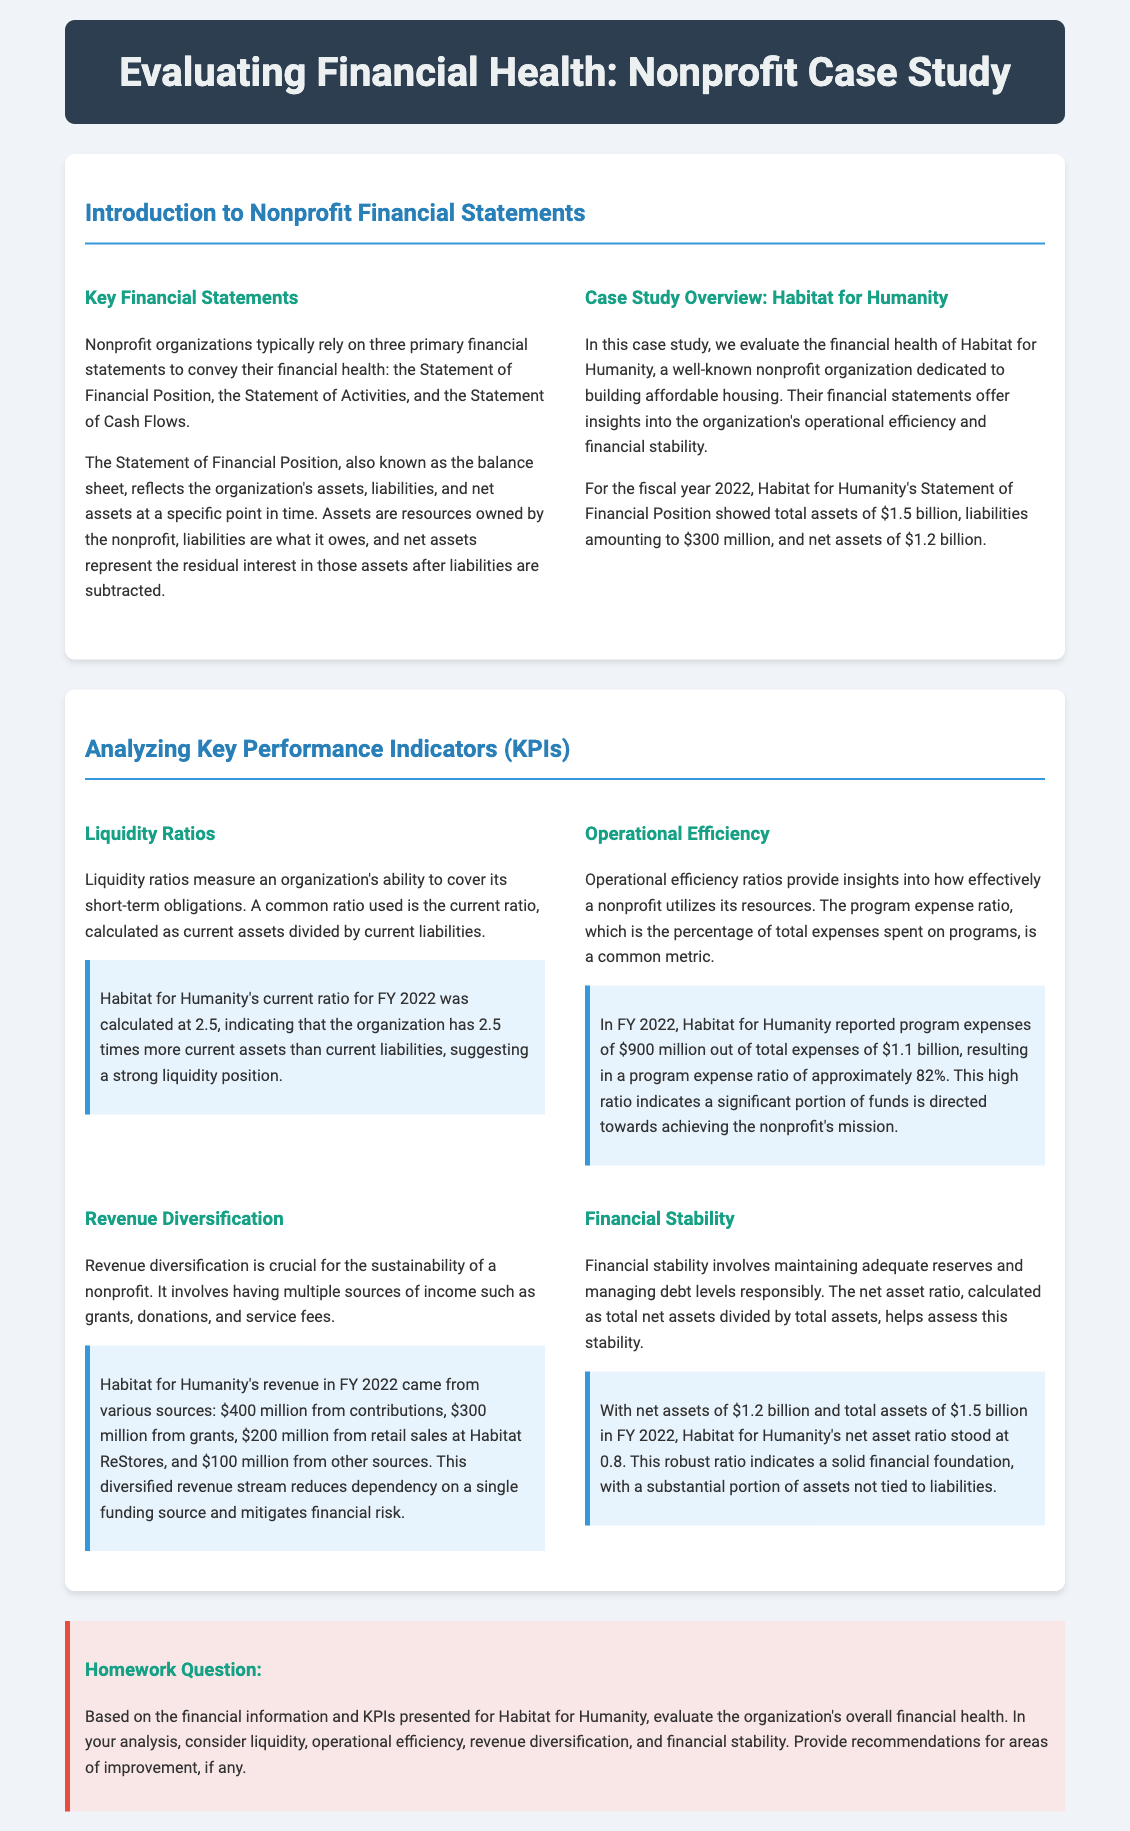What are the three primary financial statements used by nonprofits? The document states that nonprofit organizations typically rely on the Statement of Financial Position, Statement of Activities, and Statement of Cash Flows.
Answer: Statement of Financial Position, Statement of Activities, Statement of Cash Flows What were Habitat for Humanity's total assets for FY 2022? According to the case study, Habitat for Humanity's total assets for FY 2022 were reported as $1.5 billion.
Answer: $1.5 billion What is Habitat for Humanity's program expense ratio for FY 2022? The document indicates that Habitat for Humanity reported a program expense ratio of approximately 82% for FY 2022.
Answer: 82% What does a current ratio of 2.5 indicate about Habitat for Humanity? The current ratio of 2.5 suggests that the organization has 2.5 times more current assets than current liabilities, indicating a strong liquidity position.
Answer: Strong liquidity position How much revenue did Habitat for Humanity generate from contributions in FY 2022? The document states that Habitat for Humanity's revenue from contributions in FY 2022 was $400 million.
Answer: $400 million What is the net asset ratio for Habitat for Humanity in FY 2022? According to the document, Habitat for Humanity's net asset ratio for FY 2022 was calculated as 0.8.
Answer: 0.8 What area does Habitat for Humanity need to improve based on the financial analysis? The homework question prompts the reader to provide recommendations for areas of improvement. The document does not specify these details, encouraging analysis.
Answer: Areas of improvement (not specified) What is the total amount reported for liabilities by Habitat for Humanity for FY 2022? The financial health analysis reports that Habitat for Humanity's liabilities amounted to $300 million for FY 2022.
Answer: $300 million 